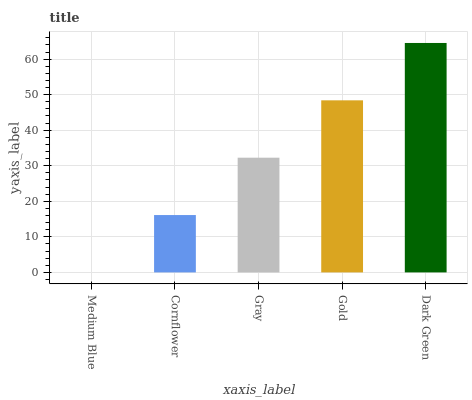Is Medium Blue the minimum?
Answer yes or no. Yes. Is Dark Green the maximum?
Answer yes or no. Yes. Is Cornflower the minimum?
Answer yes or no. No. Is Cornflower the maximum?
Answer yes or no. No. Is Cornflower greater than Medium Blue?
Answer yes or no. Yes. Is Medium Blue less than Cornflower?
Answer yes or no. Yes. Is Medium Blue greater than Cornflower?
Answer yes or no. No. Is Cornflower less than Medium Blue?
Answer yes or no. No. Is Gray the high median?
Answer yes or no. Yes. Is Gray the low median?
Answer yes or no. Yes. Is Medium Blue the high median?
Answer yes or no. No. Is Medium Blue the low median?
Answer yes or no. No. 